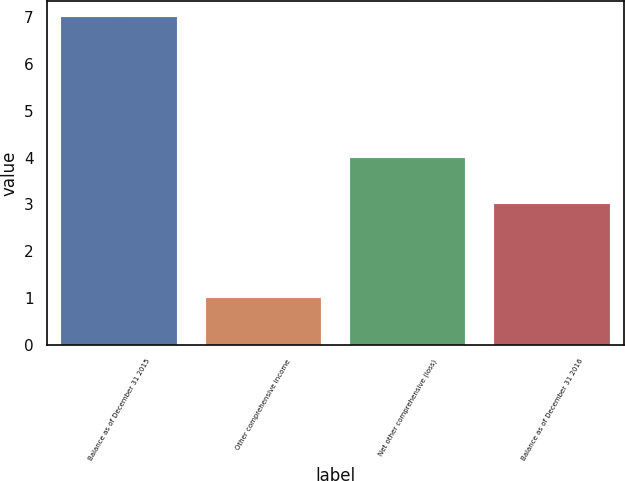Convert chart. <chart><loc_0><loc_0><loc_500><loc_500><bar_chart><fcel>Balance as of December 31 2015<fcel>Other comprehensive income<fcel>Net other comprehensive (loss)<fcel>Balance as of December 31 2016<nl><fcel>7<fcel>1<fcel>4<fcel>3<nl></chart> 